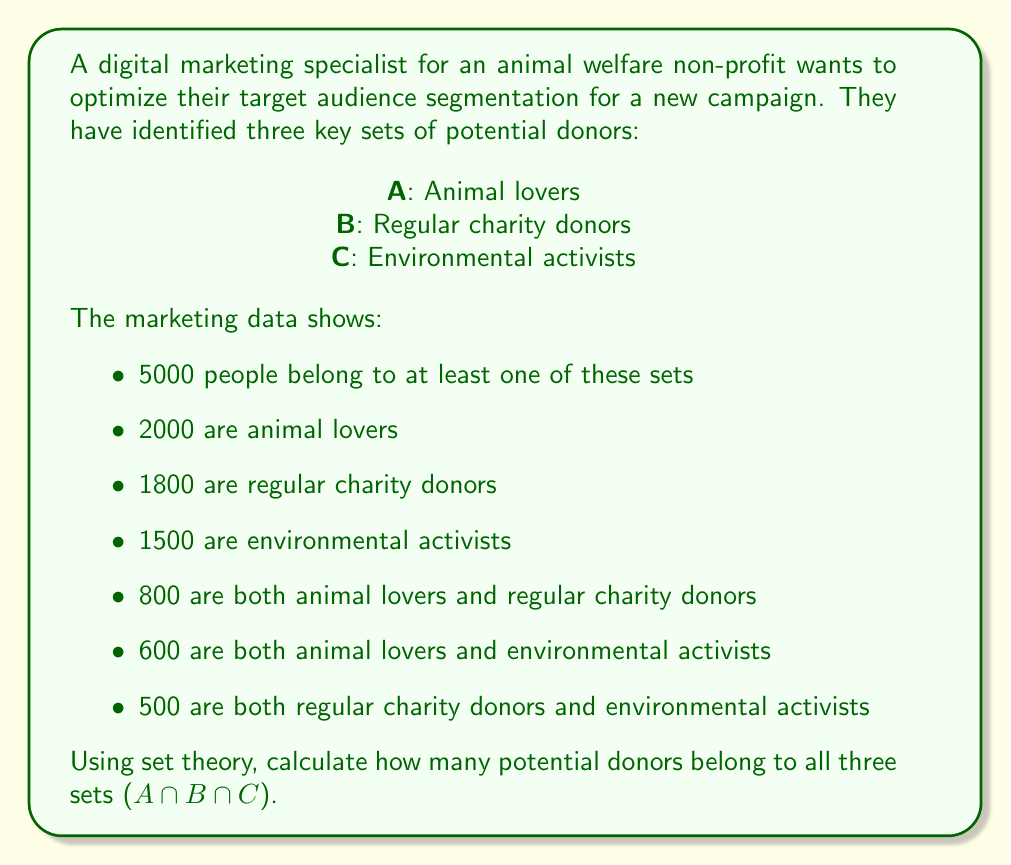Help me with this question. To solve this problem, we'll use the Inclusion-Exclusion Principle from set theory. This principle is particularly useful in marketing for understanding overlapping audience segments.

Let's define our sets:
A: Animal lovers
B: Regular charity donors
C: Environmental activists

Given:
- |A ∪ B ∪ C| = 5000 (total potential donors)
- |A| = 2000
- |B| = 1800
- |C| = 1500
- |A ∩ B| = 800
- |A ∩ C| = 600
- |B ∩ C| = 500

The Inclusion-Exclusion Principle states:

$$ |A ∪ B ∪ C| = |A| + |B| + |C| - |A ∩ B| - |A ∩ C| - |B ∩ C| + |A ∩ B ∩ C| $$

We can rearrange this to solve for |A ∩ B ∩ C|:

$$ |A ∩ B ∩ C| = |A ∪ B ∪ C| - (|A| + |B| + |C|) + (|A ∩ B| + |A ∩ C| + |B ∩ C|) $$

Now, let's substitute the known values:

$$ |A ∩ B ∩ C| = 5000 - (2000 + 1800 + 1500) + (800 + 600 + 500) $$

$$ |A ∩ B ∩ C| = 5000 - 5300 + 1900 $$

$$ |A ∩ B ∩ C| = 1600 $$

Therefore, 1600 potential donors belong to all three sets.
Answer: 1600 potential donors 